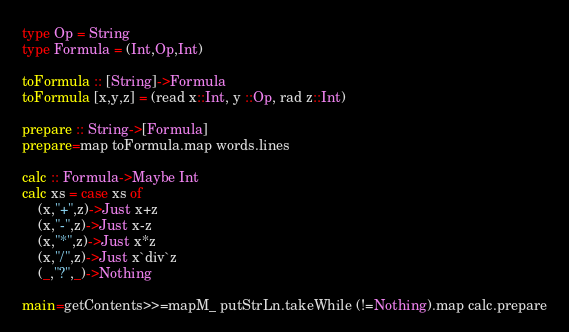<code> <loc_0><loc_0><loc_500><loc_500><_Haskell_>type Op = String
type Formula = (Int,Op,Int)

toFormula :: [String]->Formula
toFormula [x,y,z] = (read x::Int, y ::Op, rad z::Int)

prepare :: String->[Formula]
prepare=map toFormula.map words.lines

calc :: Formula->Maybe Int
calc xs = case xs of
	(x,"+",z)->Just x+z
	(x,"-",z)->Just x-z
	(x,"*",z)->Just x*z
	(x,"/",z)->Just x`div`z
	(_,"?",_)->Nothing

main=getContents>>=mapM_ putStrLn.takeWhile (!=Nothing).map calc.prepare</code> 